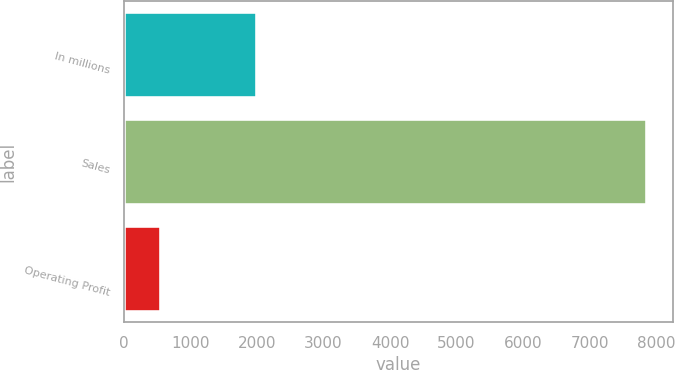<chart> <loc_0><loc_0><loc_500><loc_500><bar_chart><fcel>In millions<fcel>Sales<fcel>Operating Profit<nl><fcel>2005<fcel>7860<fcel>552<nl></chart> 